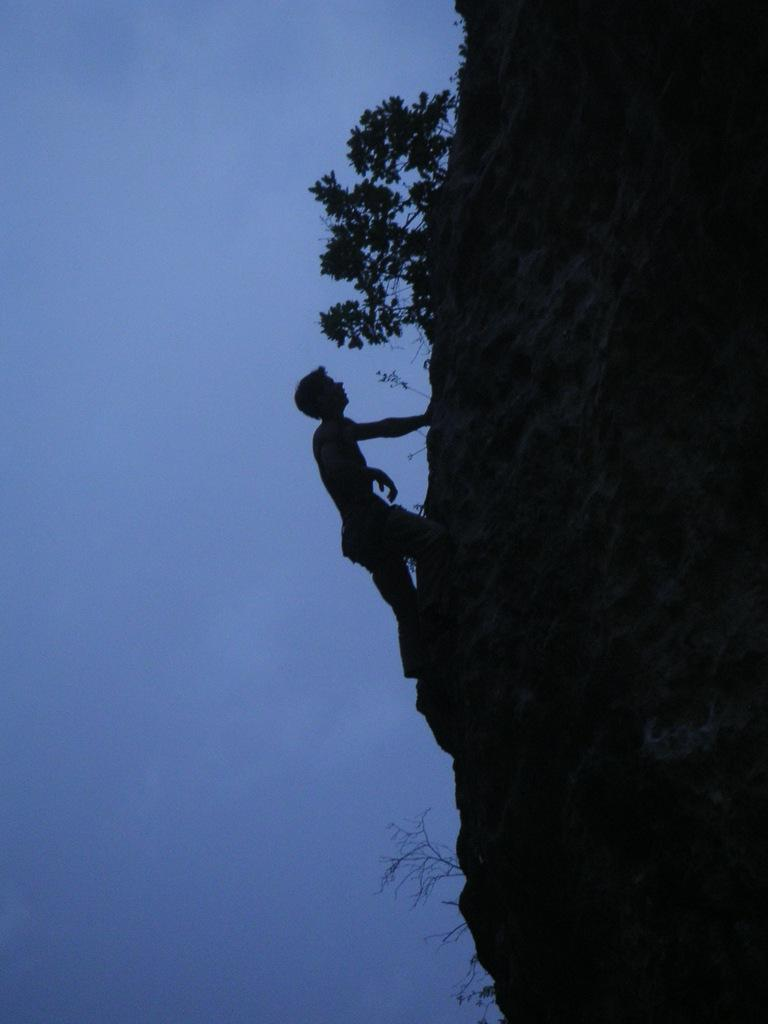Who is the main subject in the image? There is a man in the image. What is the man doing in the image? The man is climbing a mountain. What type of natural environment is visible in the image? Plants are visible in the image. What type of scissors can be seen in the image? There are no scissors present in the image. How does the man make his selection while climbing the mountain in the image? The image does not show the man making any selections while climbing the mountain. 